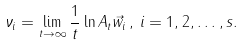Convert formula to latex. <formula><loc_0><loc_0><loc_500><loc_500>\nu _ { i } = \lim _ { t \rightarrow \infty } \frac { 1 } { t } \ln \| A _ { t } \vec { w } _ { i } \| \, , \, i = 1 , 2 , \dots , s .</formula> 